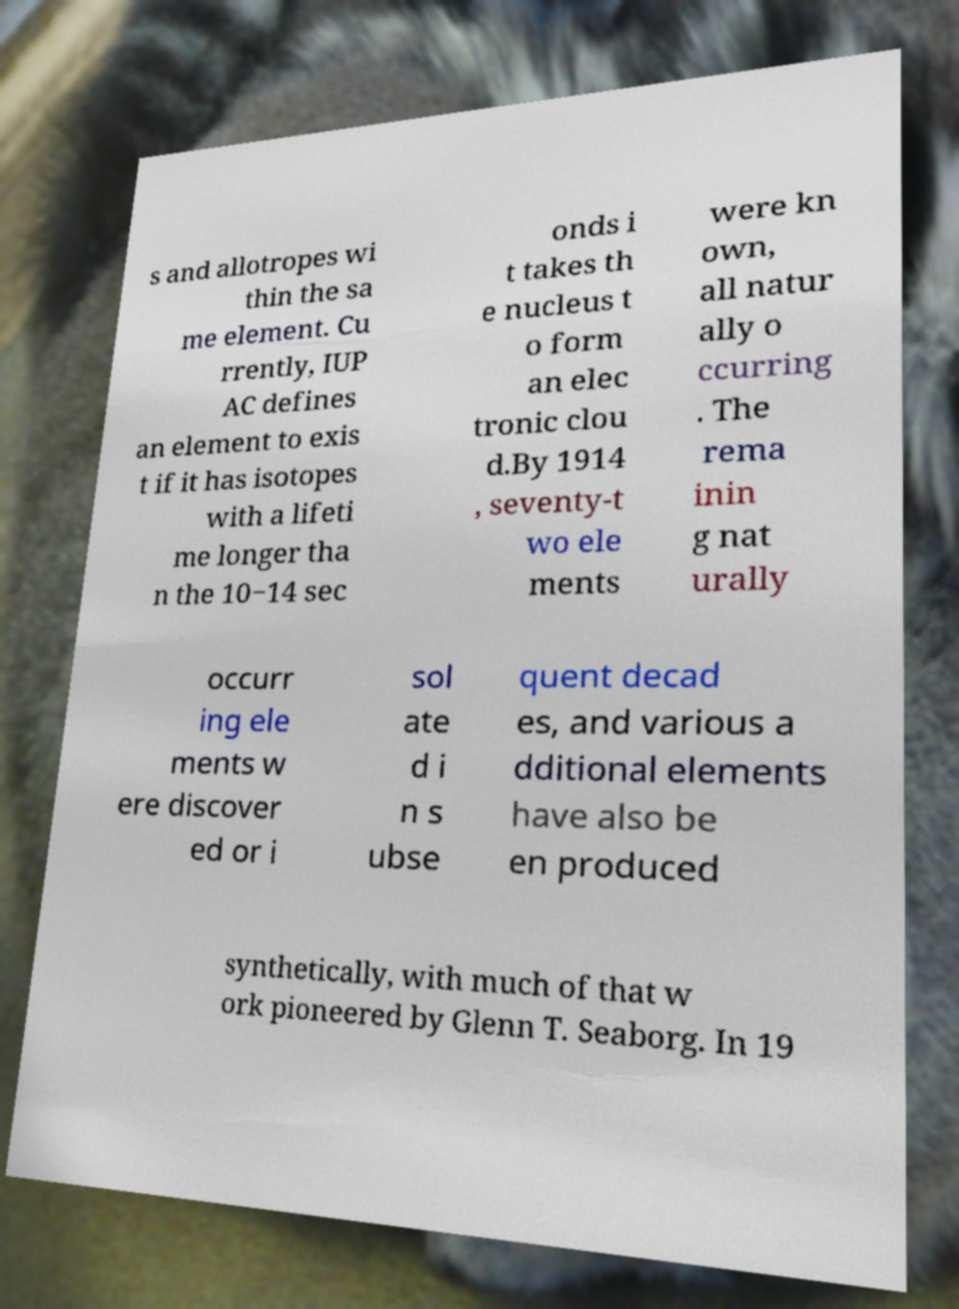I need the written content from this picture converted into text. Can you do that? s and allotropes wi thin the sa me element. Cu rrently, IUP AC defines an element to exis t if it has isotopes with a lifeti me longer tha n the 10−14 sec onds i t takes th e nucleus t o form an elec tronic clou d.By 1914 , seventy-t wo ele ments were kn own, all natur ally o ccurring . The rema inin g nat urally occurr ing ele ments w ere discover ed or i sol ate d i n s ubse quent decad es, and various a dditional elements have also be en produced synthetically, with much of that w ork pioneered by Glenn T. Seaborg. In 19 